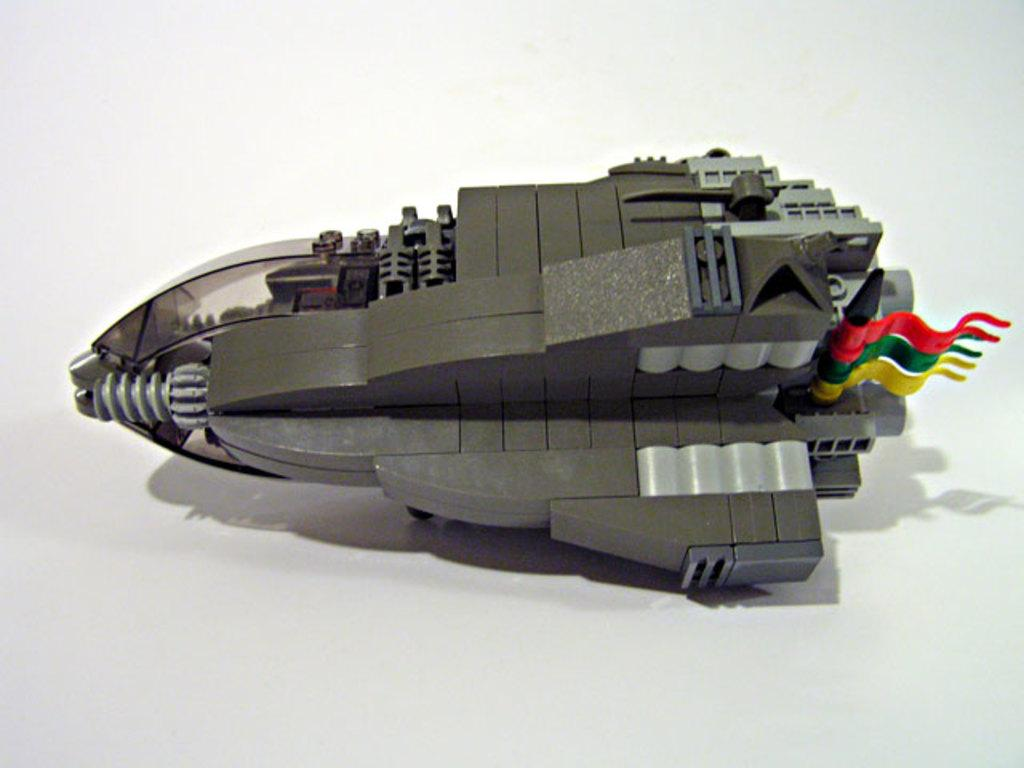What type of toy is visible in the image? There is a toy in the image that looks like a jet. Where is the toy located in the image? The toy is kept on a table. How does the jet toy produce steam in the image? The jet toy does not produce steam in the image, as it is a toy and not a real jet. Can you tell me how many times the toy has been folded in the image? The toy has not been folded in the image, as it is a jet toy and not a foldable object. 